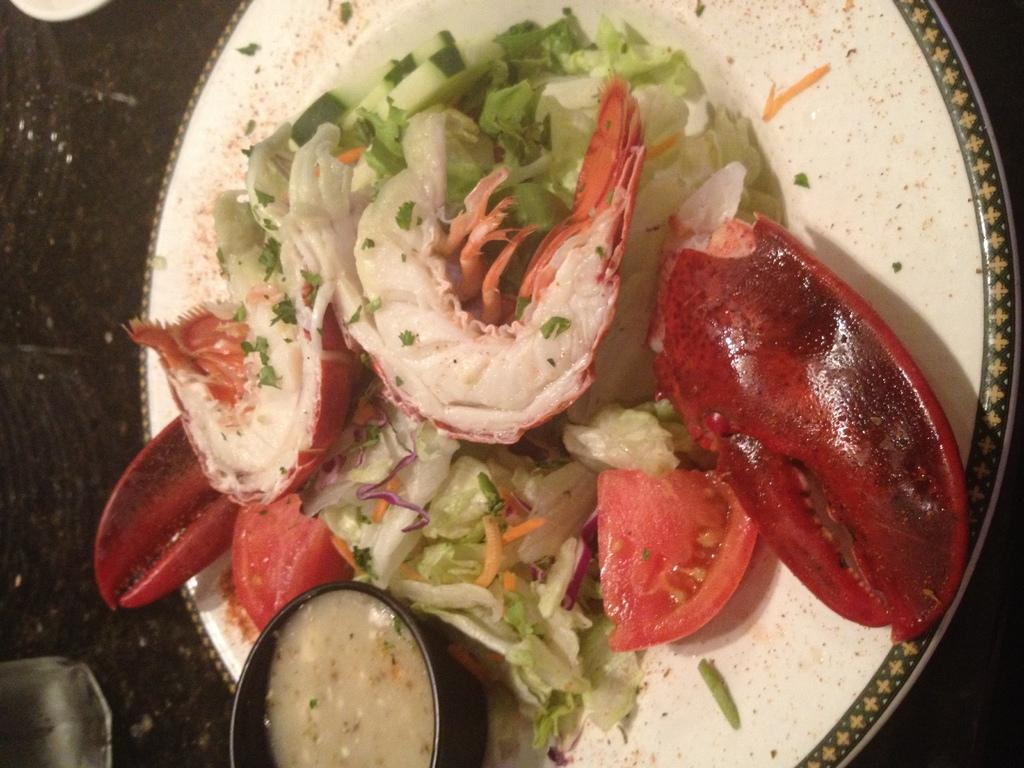What type of vegetable can be seen in the image? There are chopped tomatoes in the image. What other type of food is visible in the image? There is green salad in the image. Are there any other food items present besides the tomatoes and salad? Yes, there are other food items in the image. How are the food items arranged in the image? The food items are placed on a plate. Where is the plate located in the image? The plate is on top of a table. What type of caption can be seen on the plate in the image? There is no caption present on the plate in the image. Can you tell me how many pumps are visible in the image? There are no pumps visible in the image. 